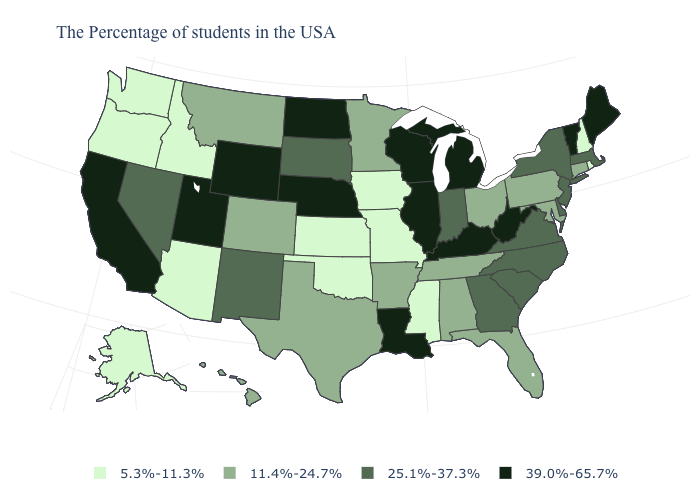How many symbols are there in the legend?
Answer briefly. 4. Does New Hampshire have the same value as Vermont?
Answer briefly. No. Among the states that border Nebraska , which have the lowest value?
Answer briefly. Missouri, Iowa, Kansas. What is the lowest value in the USA?
Keep it brief. 5.3%-11.3%. What is the value of Utah?
Quick response, please. 39.0%-65.7%. Name the states that have a value in the range 11.4%-24.7%?
Short answer required. Connecticut, Maryland, Pennsylvania, Ohio, Florida, Alabama, Tennessee, Arkansas, Minnesota, Texas, Colorado, Montana, Hawaii. Among the states that border Virginia , does North Carolina have the highest value?
Quick response, please. No. Does Massachusetts have the same value as South Carolina?
Be succinct. Yes. Is the legend a continuous bar?
Write a very short answer. No. Among the states that border Montana , which have the highest value?
Short answer required. North Dakota, Wyoming. Does Wyoming have the highest value in the USA?
Answer briefly. Yes. Among the states that border Florida , does Alabama have the highest value?
Quick response, please. No. What is the highest value in the USA?
Quick response, please. 39.0%-65.7%. What is the lowest value in the South?
Concise answer only. 5.3%-11.3%. Which states hav the highest value in the MidWest?
Write a very short answer. Michigan, Wisconsin, Illinois, Nebraska, North Dakota. 